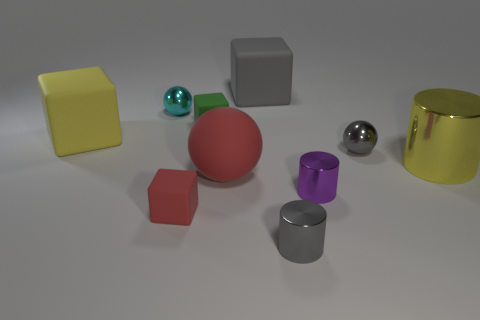Subtract all small red cubes. How many cubes are left? 3 Subtract 1 spheres. How many spheres are left? 2 Subtract all red balls. How many balls are left? 2 Subtract all blocks. How many objects are left? 6 Subtract all blue spheres. How many red cubes are left? 1 Add 3 large yellow blocks. How many large yellow blocks exist? 4 Subtract 0 cyan blocks. How many objects are left? 10 Subtract all cyan blocks. Subtract all yellow cylinders. How many blocks are left? 4 Subtract all purple cylinders. Subtract all big matte objects. How many objects are left? 6 Add 3 large red rubber things. How many large red rubber things are left? 4 